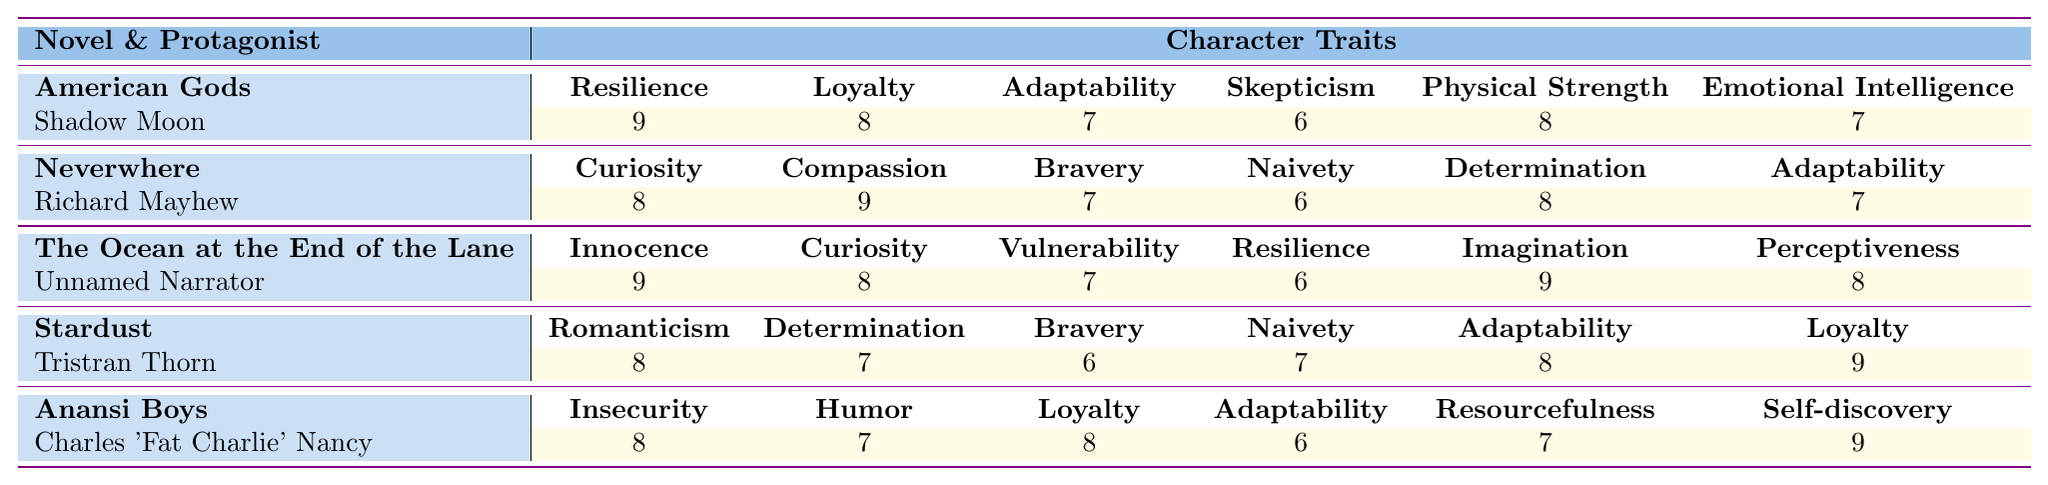What is the resilience score of Shadow Moon? The table shows that Shadow Moon, the protagonist of American Gods, has a resilience score of 9 listed under his traits.
Answer: 9 Which protagonist has the highest loyalty score? Looking through the table, Tristran Thorn from Stardust and Charles 'Fat Charlie' Nancy from Anansi Boys both have a loyalty score of 9, which is the highest among the characters.
Answer: 9 What is the adaptability score of the Unnamed Narrator? The table indicates that the Unnamed Narrator from The Ocean at the End of the Lane has an adaptability score of 7.
Answer: 7 What is the average imagination score of the protagonists? The imagination score for only one protagonist, the Unnamed Narrator from The Ocean at the End of the Lane, is 9. Since there are no other scores in this category, the average is 9.
Answer: 9 Is Richard Mayhew more compassionate than brave? Richard Mayhew has a compassion score of 9, which is higher than his bravery score of 7, indicating he is indeed more compassionate than brave.
Answer: Yes Which protagonist exhibits the most innocence? According to the table, the Unnamed Narrator from The Ocean at the End of the Lane has the highest innocence score of 9, making him the character with the most innocence.
Answer: Unnamed Narrator What is the total loyalty score of the characters in the table? To find the total loyalty score, add the loyalty scores: Shadow Moon (8) + Richard Mayhew (9) + Tristran Thorn (9) + Charles 'Fat Charlie' Nancy (8) = 34.
Answer: 34 Are there any protagonists with a vulnerability score of 9? The table shows that none of the protagonists have a vulnerability score of 9; the highest vulnerability score listed is 7 for the Unnamed Narrator.
Answer: No Which two protagonists have the same adaptability score? Both Richard Mayhew and Tristran Thorn have an adaptability score of 7 according to the table, indicating they share this trait level.
Answer: Richard Mayhew and Tristran Thorn What is the difference between the resilience scores of Shadow Moon and the Unnamed Narrator? The resilience score of Shadow Moon is 9, while the Unnamed Narrator's score is 6. The difference is 9 - 6 = 3.
Answer: 3 Which character traits are unique to each protagonist? Each protagonist has traits that are not shared with others: Shadow Moon has skepticism and physical strength, Richard Mayhew has naivety, the Unnamed Narrator has imagination, Tristran Thorn has romanticism, and Charles 'Fat Charlie' Nancy has insecurity and humor.
Answer: Various unique traits per character 